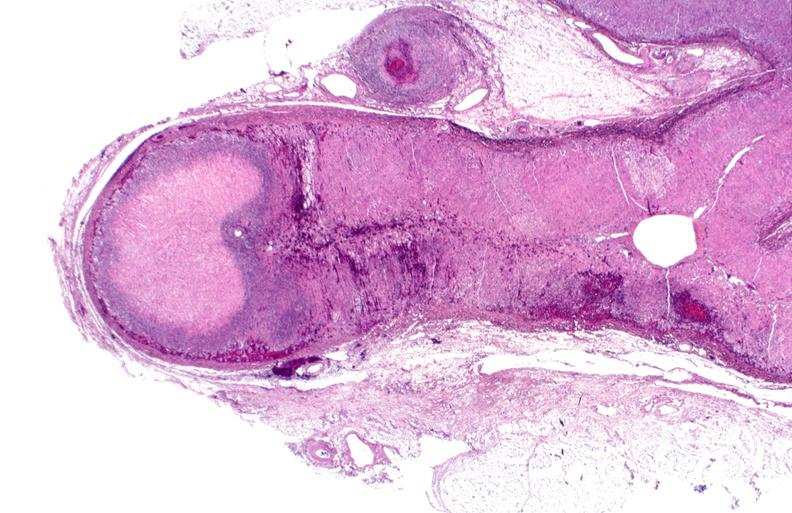s endocrine present?
Answer the question using a single word or phrase. Yes 